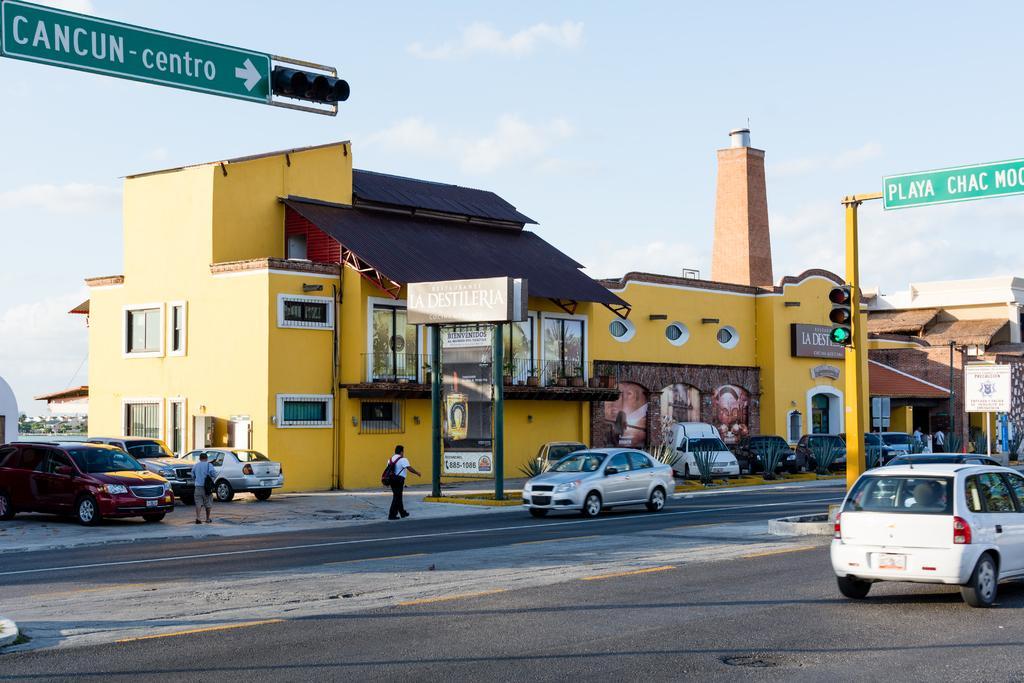Can you describe this image briefly? In this image there are vehicles, road, buildings, trees, signal lights and boards attached to the poles, hoardings, group of people standing, sky. 